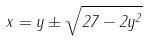<formula> <loc_0><loc_0><loc_500><loc_500>x = y \pm \sqrt { 2 7 - 2 y ^ { 2 } }</formula> 